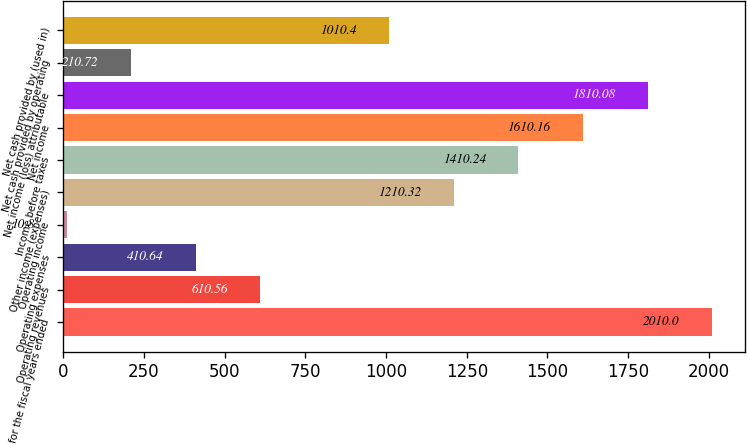<chart> <loc_0><loc_0><loc_500><loc_500><bar_chart><fcel>for the fiscal years ended<fcel>Operating revenues<fcel>Operating expenses<fcel>Operating income<fcel>Other income (expenses)<fcel>Income before taxes<fcel>Net income<fcel>Net income (loss) attributable<fcel>Net cash provided by operating<fcel>Net cash provided by (used in)<nl><fcel>2010<fcel>610.56<fcel>410.64<fcel>10.8<fcel>1210.32<fcel>1410.24<fcel>1610.16<fcel>1810.08<fcel>210.72<fcel>1010.4<nl></chart> 